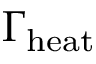<formula> <loc_0><loc_0><loc_500><loc_500>\Gamma _ { h e a t }</formula> 